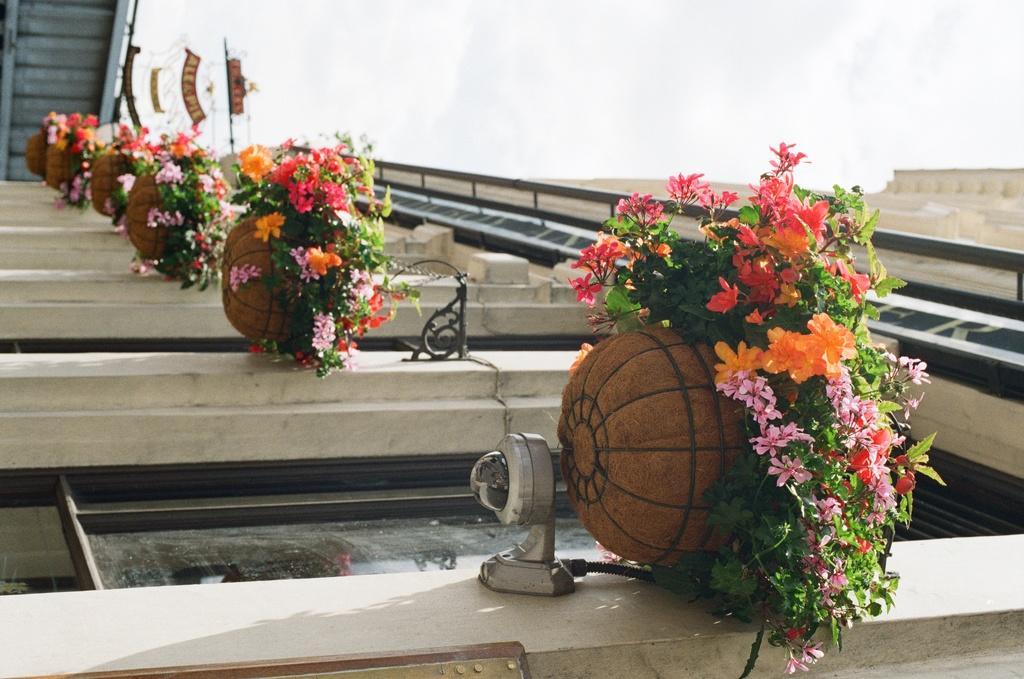Can you describe this image briefly? This picture is clicked outside. In the foreground we can see the potted plants and flowers, we can see the building and the metal rods. In the background we can see the sky and some other objects. 